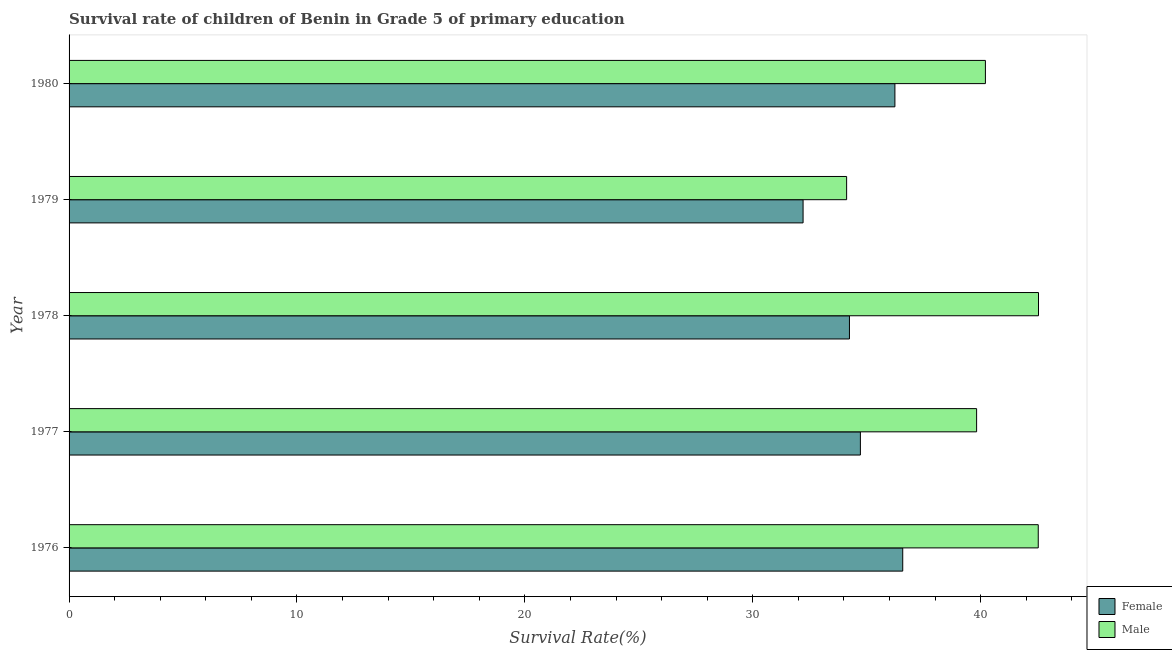How many different coloured bars are there?
Offer a terse response. 2. How many groups of bars are there?
Provide a short and direct response. 5. How many bars are there on the 1st tick from the bottom?
Offer a terse response. 2. What is the label of the 2nd group of bars from the top?
Offer a very short reply. 1979. In how many cases, is the number of bars for a given year not equal to the number of legend labels?
Your answer should be very brief. 0. What is the survival rate of female students in primary education in 1976?
Offer a terse response. 36.58. Across all years, what is the maximum survival rate of female students in primary education?
Offer a very short reply. 36.58. Across all years, what is the minimum survival rate of male students in primary education?
Ensure brevity in your answer.  34.12. In which year was the survival rate of female students in primary education maximum?
Offer a terse response. 1976. In which year was the survival rate of male students in primary education minimum?
Give a very brief answer. 1979. What is the total survival rate of male students in primary education in the graph?
Your response must be concise. 199.21. What is the difference between the survival rate of female students in primary education in 1978 and that in 1979?
Your answer should be compact. 2.04. What is the difference between the survival rate of female students in primary education in 1976 and the survival rate of male students in primary education in 1977?
Your response must be concise. -3.24. What is the average survival rate of male students in primary education per year?
Offer a very short reply. 39.84. In the year 1979, what is the difference between the survival rate of male students in primary education and survival rate of female students in primary education?
Give a very brief answer. 1.91. What is the ratio of the survival rate of male students in primary education in 1976 to that in 1977?
Keep it short and to the point. 1.07. What is the difference between the highest and the second highest survival rate of male students in primary education?
Make the answer very short. 0.01. What is the difference between the highest and the lowest survival rate of female students in primary education?
Keep it short and to the point. 4.37. In how many years, is the survival rate of male students in primary education greater than the average survival rate of male students in primary education taken over all years?
Your answer should be compact. 3. What does the 2nd bar from the bottom in 1978 represents?
Offer a terse response. Male. Are all the bars in the graph horizontal?
Make the answer very short. Yes. Are the values on the major ticks of X-axis written in scientific E-notation?
Provide a short and direct response. No. Does the graph contain any zero values?
Offer a very short reply. No. Does the graph contain grids?
Ensure brevity in your answer.  No. Where does the legend appear in the graph?
Your response must be concise. Bottom right. How are the legend labels stacked?
Ensure brevity in your answer.  Vertical. What is the title of the graph?
Your response must be concise. Survival rate of children of Benin in Grade 5 of primary education. Does "Quality of trade" appear as one of the legend labels in the graph?
Keep it short and to the point. No. What is the label or title of the X-axis?
Give a very brief answer. Survival Rate(%). What is the label or title of the Y-axis?
Make the answer very short. Year. What is the Survival Rate(%) of Female in 1976?
Your answer should be very brief. 36.58. What is the Survival Rate(%) in Male in 1976?
Ensure brevity in your answer.  42.53. What is the Survival Rate(%) in Female in 1977?
Give a very brief answer. 34.72. What is the Survival Rate(%) in Male in 1977?
Provide a succinct answer. 39.82. What is the Survival Rate(%) of Female in 1978?
Keep it short and to the point. 34.24. What is the Survival Rate(%) in Male in 1978?
Provide a short and direct response. 42.54. What is the Survival Rate(%) of Female in 1979?
Give a very brief answer. 32.21. What is the Survival Rate(%) of Male in 1979?
Offer a very short reply. 34.12. What is the Survival Rate(%) in Female in 1980?
Your response must be concise. 36.24. What is the Survival Rate(%) in Male in 1980?
Your response must be concise. 40.21. Across all years, what is the maximum Survival Rate(%) of Female?
Your answer should be very brief. 36.58. Across all years, what is the maximum Survival Rate(%) of Male?
Offer a very short reply. 42.54. Across all years, what is the minimum Survival Rate(%) of Female?
Offer a terse response. 32.21. Across all years, what is the minimum Survival Rate(%) in Male?
Give a very brief answer. 34.12. What is the total Survival Rate(%) of Female in the graph?
Provide a short and direct response. 173.99. What is the total Survival Rate(%) in Male in the graph?
Your answer should be compact. 199.21. What is the difference between the Survival Rate(%) in Female in 1976 and that in 1977?
Keep it short and to the point. 1.86. What is the difference between the Survival Rate(%) in Male in 1976 and that in 1977?
Provide a succinct answer. 2.7. What is the difference between the Survival Rate(%) in Female in 1976 and that in 1978?
Offer a terse response. 2.34. What is the difference between the Survival Rate(%) in Male in 1976 and that in 1978?
Your answer should be compact. -0.01. What is the difference between the Survival Rate(%) in Female in 1976 and that in 1979?
Provide a short and direct response. 4.37. What is the difference between the Survival Rate(%) of Male in 1976 and that in 1979?
Give a very brief answer. 8.41. What is the difference between the Survival Rate(%) of Female in 1976 and that in 1980?
Your response must be concise. 0.34. What is the difference between the Survival Rate(%) of Male in 1976 and that in 1980?
Offer a very short reply. 2.32. What is the difference between the Survival Rate(%) of Female in 1977 and that in 1978?
Offer a very short reply. 0.48. What is the difference between the Survival Rate(%) of Male in 1977 and that in 1978?
Your answer should be compact. -2.72. What is the difference between the Survival Rate(%) of Female in 1977 and that in 1979?
Offer a very short reply. 2.51. What is the difference between the Survival Rate(%) of Male in 1977 and that in 1979?
Ensure brevity in your answer.  5.7. What is the difference between the Survival Rate(%) in Female in 1977 and that in 1980?
Your answer should be very brief. -1.51. What is the difference between the Survival Rate(%) of Male in 1977 and that in 1980?
Ensure brevity in your answer.  -0.39. What is the difference between the Survival Rate(%) of Female in 1978 and that in 1979?
Make the answer very short. 2.03. What is the difference between the Survival Rate(%) in Male in 1978 and that in 1979?
Offer a very short reply. 8.42. What is the difference between the Survival Rate(%) of Female in 1978 and that in 1980?
Keep it short and to the point. -1.99. What is the difference between the Survival Rate(%) of Male in 1978 and that in 1980?
Ensure brevity in your answer.  2.33. What is the difference between the Survival Rate(%) in Female in 1979 and that in 1980?
Your answer should be compact. -4.03. What is the difference between the Survival Rate(%) in Male in 1979 and that in 1980?
Give a very brief answer. -6.09. What is the difference between the Survival Rate(%) in Female in 1976 and the Survival Rate(%) in Male in 1977?
Offer a terse response. -3.24. What is the difference between the Survival Rate(%) of Female in 1976 and the Survival Rate(%) of Male in 1978?
Make the answer very short. -5.96. What is the difference between the Survival Rate(%) of Female in 1976 and the Survival Rate(%) of Male in 1979?
Provide a succinct answer. 2.46. What is the difference between the Survival Rate(%) of Female in 1976 and the Survival Rate(%) of Male in 1980?
Make the answer very short. -3.63. What is the difference between the Survival Rate(%) in Female in 1977 and the Survival Rate(%) in Male in 1978?
Provide a succinct answer. -7.82. What is the difference between the Survival Rate(%) of Female in 1977 and the Survival Rate(%) of Male in 1979?
Offer a terse response. 0.6. What is the difference between the Survival Rate(%) of Female in 1977 and the Survival Rate(%) of Male in 1980?
Your answer should be very brief. -5.49. What is the difference between the Survival Rate(%) of Female in 1978 and the Survival Rate(%) of Male in 1979?
Ensure brevity in your answer.  0.12. What is the difference between the Survival Rate(%) in Female in 1978 and the Survival Rate(%) in Male in 1980?
Your response must be concise. -5.97. What is the difference between the Survival Rate(%) of Female in 1979 and the Survival Rate(%) of Male in 1980?
Your response must be concise. -8. What is the average Survival Rate(%) in Female per year?
Offer a terse response. 34.8. What is the average Survival Rate(%) in Male per year?
Your answer should be very brief. 39.84. In the year 1976, what is the difference between the Survival Rate(%) in Female and Survival Rate(%) in Male?
Offer a terse response. -5.95. In the year 1977, what is the difference between the Survival Rate(%) in Female and Survival Rate(%) in Male?
Give a very brief answer. -5.1. In the year 1978, what is the difference between the Survival Rate(%) of Female and Survival Rate(%) of Male?
Your answer should be compact. -8.3. In the year 1979, what is the difference between the Survival Rate(%) of Female and Survival Rate(%) of Male?
Your response must be concise. -1.91. In the year 1980, what is the difference between the Survival Rate(%) in Female and Survival Rate(%) in Male?
Ensure brevity in your answer.  -3.97. What is the ratio of the Survival Rate(%) of Female in 1976 to that in 1977?
Ensure brevity in your answer.  1.05. What is the ratio of the Survival Rate(%) in Male in 1976 to that in 1977?
Provide a short and direct response. 1.07. What is the ratio of the Survival Rate(%) of Female in 1976 to that in 1978?
Your response must be concise. 1.07. What is the ratio of the Survival Rate(%) in Female in 1976 to that in 1979?
Provide a succinct answer. 1.14. What is the ratio of the Survival Rate(%) of Male in 1976 to that in 1979?
Your answer should be very brief. 1.25. What is the ratio of the Survival Rate(%) in Female in 1976 to that in 1980?
Offer a very short reply. 1.01. What is the ratio of the Survival Rate(%) in Male in 1976 to that in 1980?
Your answer should be compact. 1.06. What is the ratio of the Survival Rate(%) of Male in 1977 to that in 1978?
Ensure brevity in your answer.  0.94. What is the ratio of the Survival Rate(%) of Female in 1977 to that in 1979?
Keep it short and to the point. 1.08. What is the ratio of the Survival Rate(%) in Male in 1977 to that in 1979?
Provide a short and direct response. 1.17. What is the ratio of the Survival Rate(%) in Female in 1977 to that in 1980?
Give a very brief answer. 0.96. What is the ratio of the Survival Rate(%) in Female in 1978 to that in 1979?
Your response must be concise. 1.06. What is the ratio of the Survival Rate(%) of Male in 1978 to that in 1979?
Offer a terse response. 1.25. What is the ratio of the Survival Rate(%) of Female in 1978 to that in 1980?
Provide a succinct answer. 0.94. What is the ratio of the Survival Rate(%) of Male in 1978 to that in 1980?
Keep it short and to the point. 1.06. What is the ratio of the Survival Rate(%) of Female in 1979 to that in 1980?
Keep it short and to the point. 0.89. What is the ratio of the Survival Rate(%) of Male in 1979 to that in 1980?
Offer a very short reply. 0.85. What is the difference between the highest and the second highest Survival Rate(%) in Female?
Make the answer very short. 0.34. What is the difference between the highest and the second highest Survival Rate(%) in Male?
Your response must be concise. 0.01. What is the difference between the highest and the lowest Survival Rate(%) in Female?
Offer a terse response. 4.37. What is the difference between the highest and the lowest Survival Rate(%) of Male?
Ensure brevity in your answer.  8.42. 